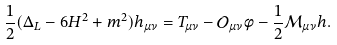<formula> <loc_0><loc_0><loc_500><loc_500>\frac { 1 } { 2 } ( \Delta _ { L } - 6 H ^ { 2 } + m ^ { 2 } ) h _ { \mu \nu } = T _ { \mu \nu } - \mathcal { O } _ { \mu \nu } \phi - \frac { 1 } { 2 } \mathcal { M } _ { \mu \nu } h .</formula> 